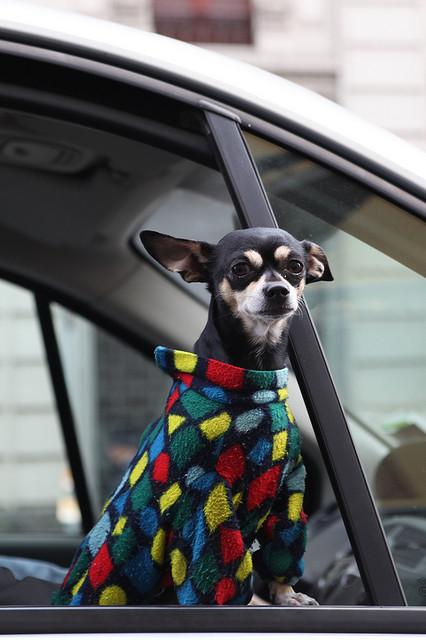How many unique colors does the dog's outfit have?
Write a very short answer. 6. Where is the dog?
Keep it brief. In car. What is the dog doing?
Concise answer only. Looking out window. 